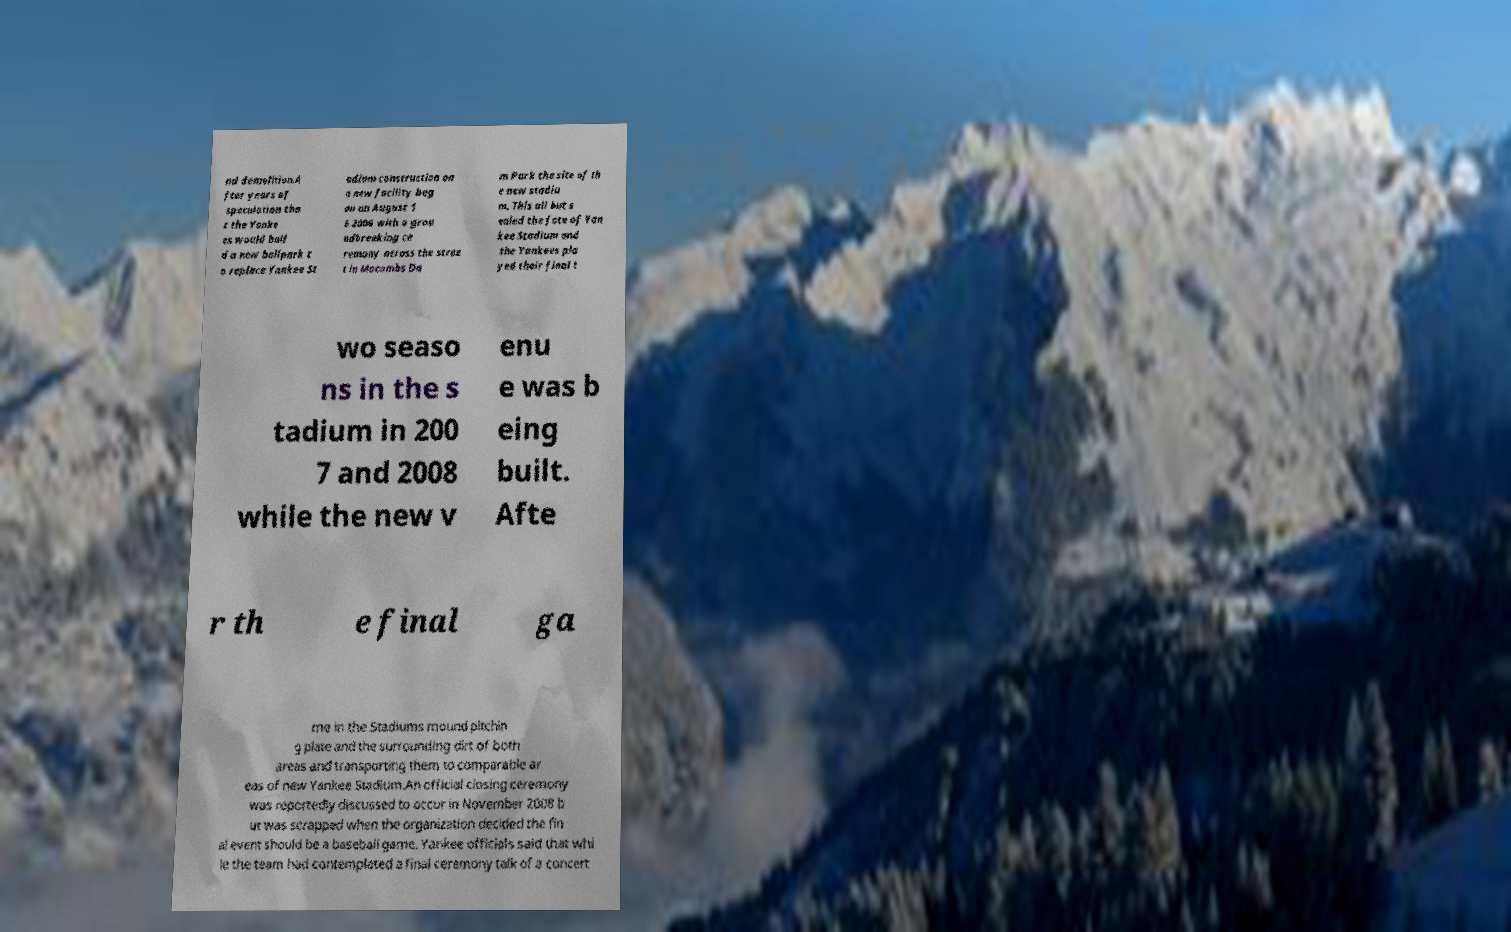What messages or text are displayed in this image? I need them in a readable, typed format. nd demolition.A fter years of speculation tha t the Yanke es would buil d a new ballpark t o replace Yankee St adium construction on a new facility beg an on August 1 6 2006 with a grou ndbreaking ce remony across the stree t in Macombs Da m Park the site of th e new stadiu m. This all but s ealed the fate of Yan kee Stadium and the Yankees pla yed their final t wo seaso ns in the s tadium in 200 7 and 2008 while the new v enu e was b eing built. Afte r th e final ga me in the Stadiums mound pitchin g plate and the surrounding dirt of both areas and transporting them to comparable ar eas of new Yankee Stadium.An official closing ceremony was reportedly discussed to occur in November 2008 b ut was scrapped when the organization decided the fin al event should be a baseball game. Yankee officials said that whi le the team had contemplated a final ceremony talk of a concert 